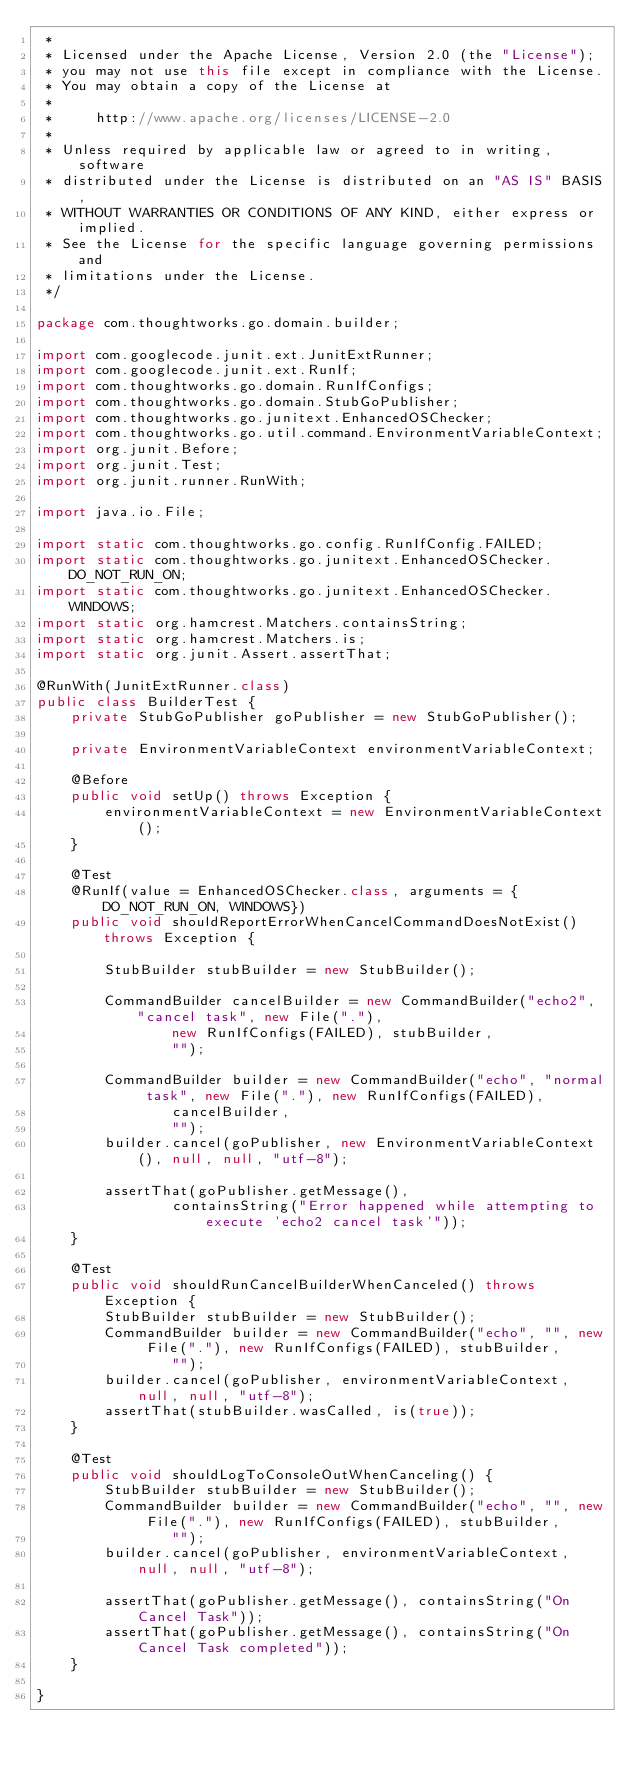Convert code to text. <code><loc_0><loc_0><loc_500><loc_500><_Java_> *
 * Licensed under the Apache License, Version 2.0 (the "License");
 * you may not use this file except in compliance with the License.
 * You may obtain a copy of the License at
 *
 *     http://www.apache.org/licenses/LICENSE-2.0
 *
 * Unless required by applicable law or agreed to in writing, software
 * distributed under the License is distributed on an "AS IS" BASIS,
 * WITHOUT WARRANTIES OR CONDITIONS OF ANY KIND, either express or implied.
 * See the License for the specific language governing permissions and
 * limitations under the License.
 */

package com.thoughtworks.go.domain.builder;

import com.googlecode.junit.ext.JunitExtRunner;
import com.googlecode.junit.ext.RunIf;
import com.thoughtworks.go.domain.RunIfConfigs;
import com.thoughtworks.go.domain.StubGoPublisher;
import com.thoughtworks.go.junitext.EnhancedOSChecker;
import com.thoughtworks.go.util.command.EnvironmentVariableContext;
import org.junit.Before;
import org.junit.Test;
import org.junit.runner.RunWith;

import java.io.File;

import static com.thoughtworks.go.config.RunIfConfig.FAILED;
import static com.thoughtworks.go.junitext.EnhancedOSChecker.DO_NOT_RUN_ON;
import static com.thoughtworks.go.junitext.EnhancedOSChecker.WINDOWS;
import static org.hamcrest.Matchers.containsString;
import static org.hamcrest.Matchers.is;
import static org.junit.Assert.assertThat;

@RunWith(JunitExtRunner.class)
public class BuilderTest {
    private StubGoPublisher goPublisher = new StubGoPublisher();

    private EnvironmentVariableContext environmentVariableContext;

    @Before
    public void setUp() throws Exception {
        environmentVariableContext = new EnvironmentVariableContext();
    }

    @Test
    @RunIf(value = EnhancedOSChecker.class, arguments = {DO_NOT_RUN_ON, WINDOWS})
    public void shouldReportErrorWhenCancelCommandDoesNotExist() throws Exception {

        StubBuilder stubBuilder = new StubBuilder();

        CommandBuilder cancelBuilder = new CommandBuilder("echo2", "cancel task", new File("."),
                new RunIfConfigs(FAILED), stubBuilder,
                "");

        CommandBuilder builder = new CommandBuilder("echo", "normal task", new File("."), new RunIfConfigs(FAILED),
                cancelBuilder,
                "");
        builder.cancel(goPublisher, new EnvironmentVariableContext(), null, null, "utf-8");

        assertThat(goPublisher.getMessage(),
                containsString("Error happened while attempting to execute 'echo2 cancel task'"));
    }

    @Test
    public void shouldRunCancelBuilderWhenCanceled() throws Exception {
        StubBuilder stubBuilder = new StubBuilder();
        CommandBuilder builder = new CommandBuilder("echo", "", new File("."), new RunIfConfigs(FAILED), stubBuilder,
                "");
        builder.cancel(goPublisher, environmentVariableContext, null, null, "utf-8");
        assertThat(stubBuilder.wasCalled, is(true));
    }

    @Test
    public void shouldLogToConsoleOutWhenCanceling() {
        StubBuilder stubBuilder = new StubBuilder();
        CommandBuilder builder = new CommandBuilder("echo", "", new File("."), new RunIfConfigs(FAILED), stubBuilder,
                "");
        builder.cancel(goPublisher, environmentVariableContext, null, null, "utf-8");

        assertThat(goPublisher.getMessage(), containsString("On Cancel Task"));
        assertThat(goPublisher.getMessage(), containsString("On Cancel Task completed"));
    }

}
</code> 